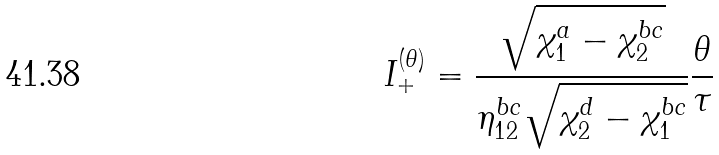Convert formula to latex. <formula><loc_0><loc_0><loc_500><loc_500>I _ { + } ^ { ( \theta ) } = \frac { \sqrt { \chi _ { 1 } ^ { a } - \chi _ { 2 } ^ { b c } } } { \eta _ { 1 2 } ^ { b c } \sqrt { \chi _ { 2 } ^ { d } - \chi _ { 1 } ^ { b c } } } \frac { \theta } { \tau }</formula> 